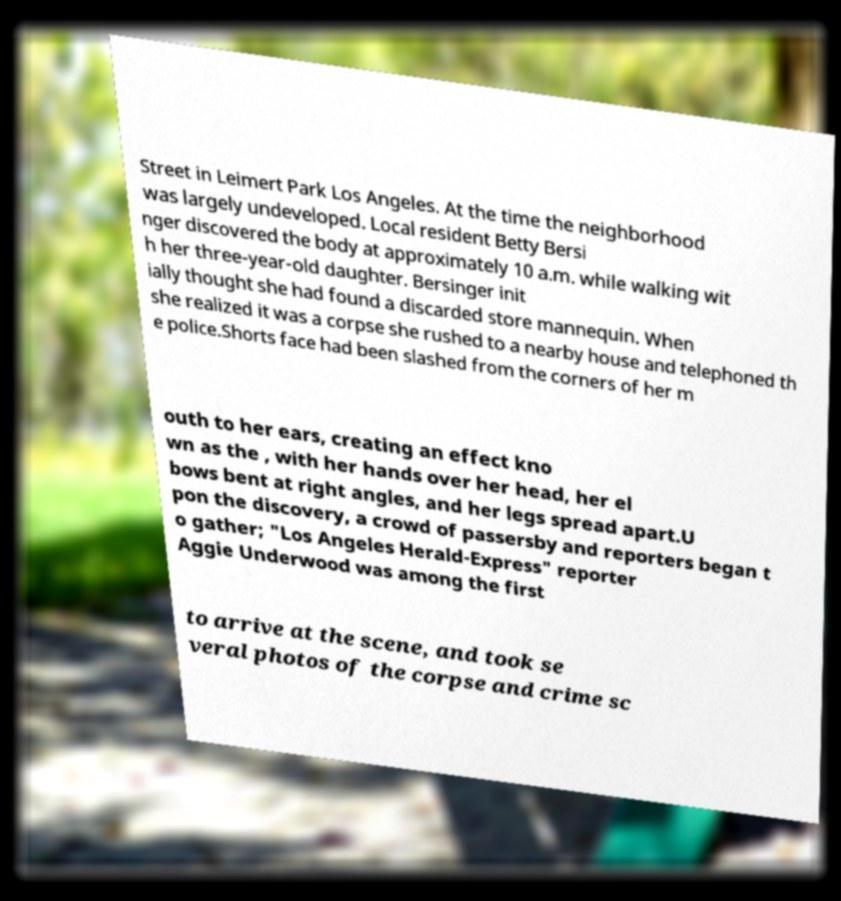Could you assist in decoding the text presented in this image and type it out clearly? Street in Leimert Park Los Angeles. At the time the neighborhood was largely undeveloped. Local resident Betty Bersi nger discovered the body at approximately 10 a.m. while walking wit h her three-year-old daughter. Bersinger init ially thought she had found a discarded store mannequin. When she realized it was a corpse she rushed to a nearby house and telephoned th e police.Shorts face had been slashed from the corners of her m outh to her ears, creating an effect kno wn as the , with her hands over her head, her el bows bent at right angles, and her legs spread apart.U pon the discovery, a crowd of passersby and reporters began t o gather; "Los Angeles Herald-Express" reporter Aggie Underwood was among the first to arrive at the scene, and took se veral photos of the corpse and crime sc 